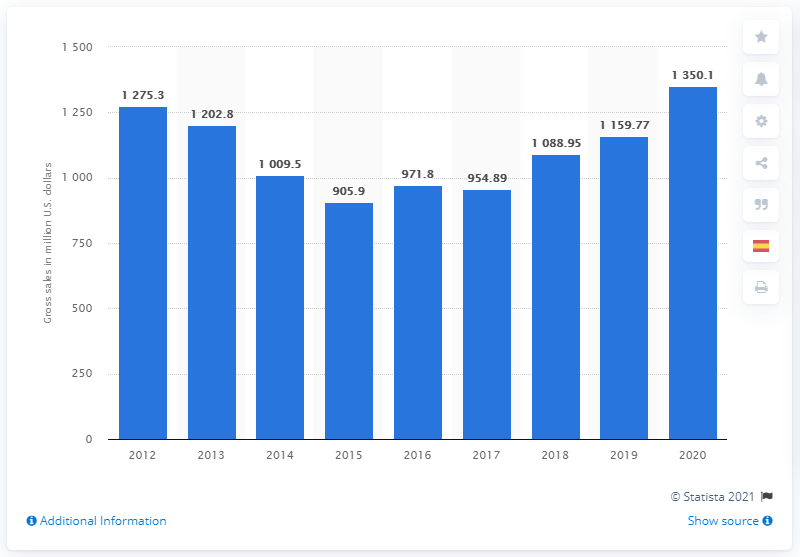Indicate a few pertinent items in this graphic. Mattel's Barbie brand generated an estimated gross sales of 1,350.1 million dollars in the United States in 2020. 